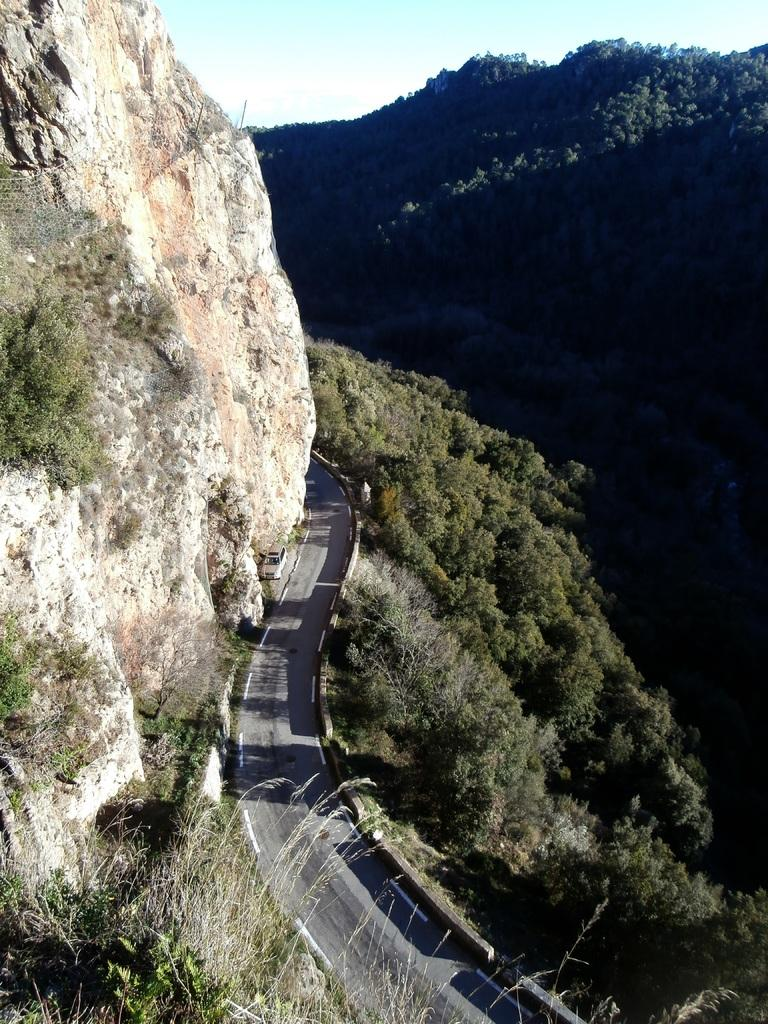What is located on the path in the image? There is a vehicle on the path in the image. What can be seen on the hill in the image? There is a rod on the hill in the image. What type of vegetation is on the right side of the road in the image? There are trees on the right side of the road in the image. What type of geographical features are visible in the image? There are hills visible in the image. What is visible in the sky in the image? The sky is visible in the image. What historical event is depicted in the image? There is no historical event depicted in the image; it shows a vehicle on a path, a rod on a hill, trees, hills, and the sky. What type of debt is being discussed in the image? There is no discussion of debt in the image; it does not contain any text or context related to financial matters. 